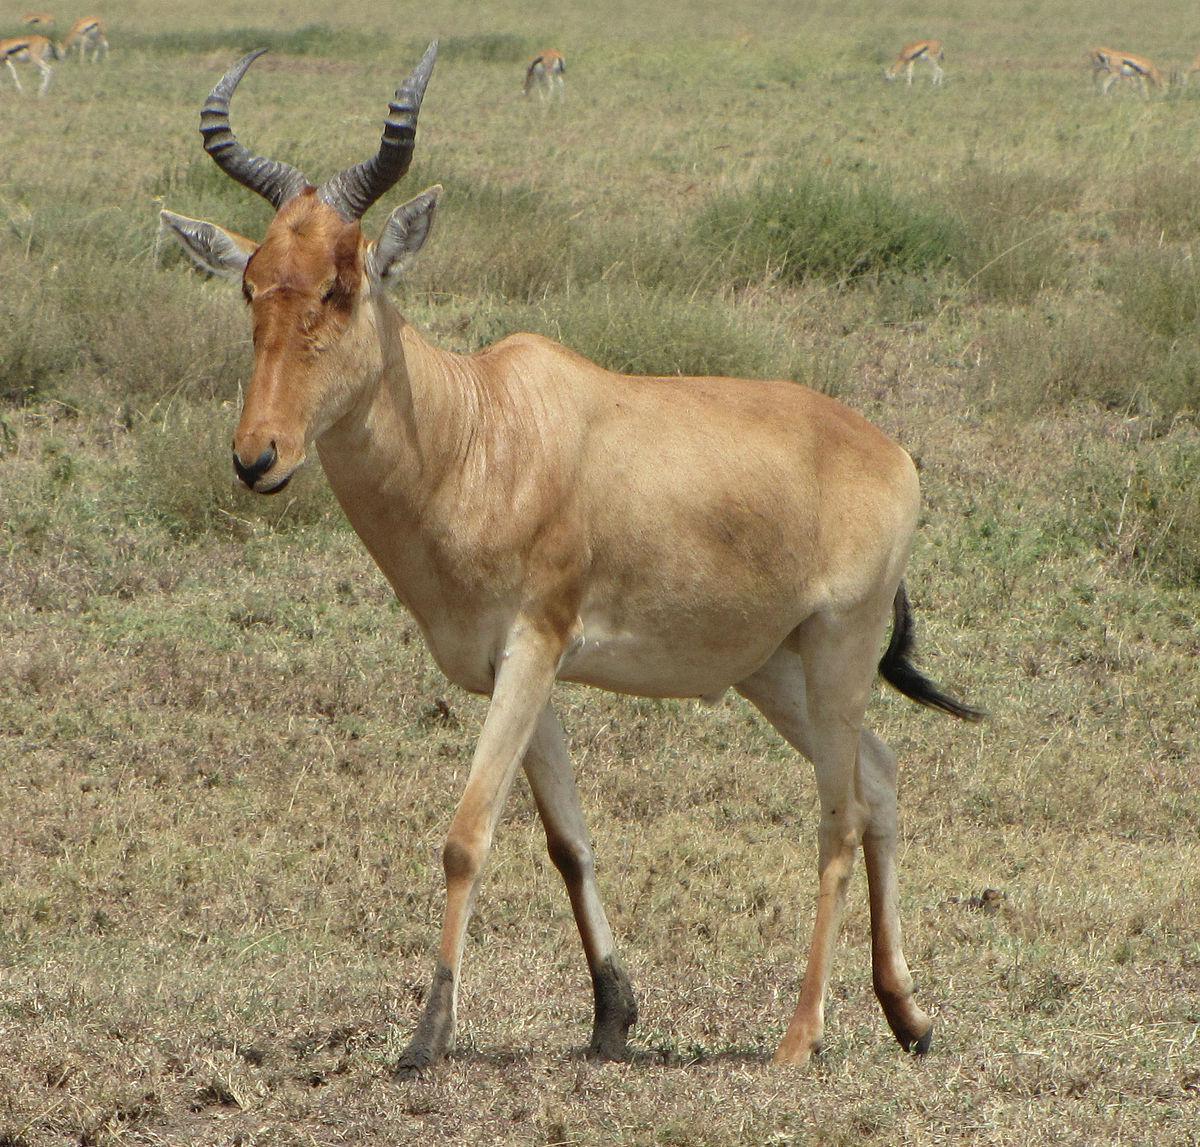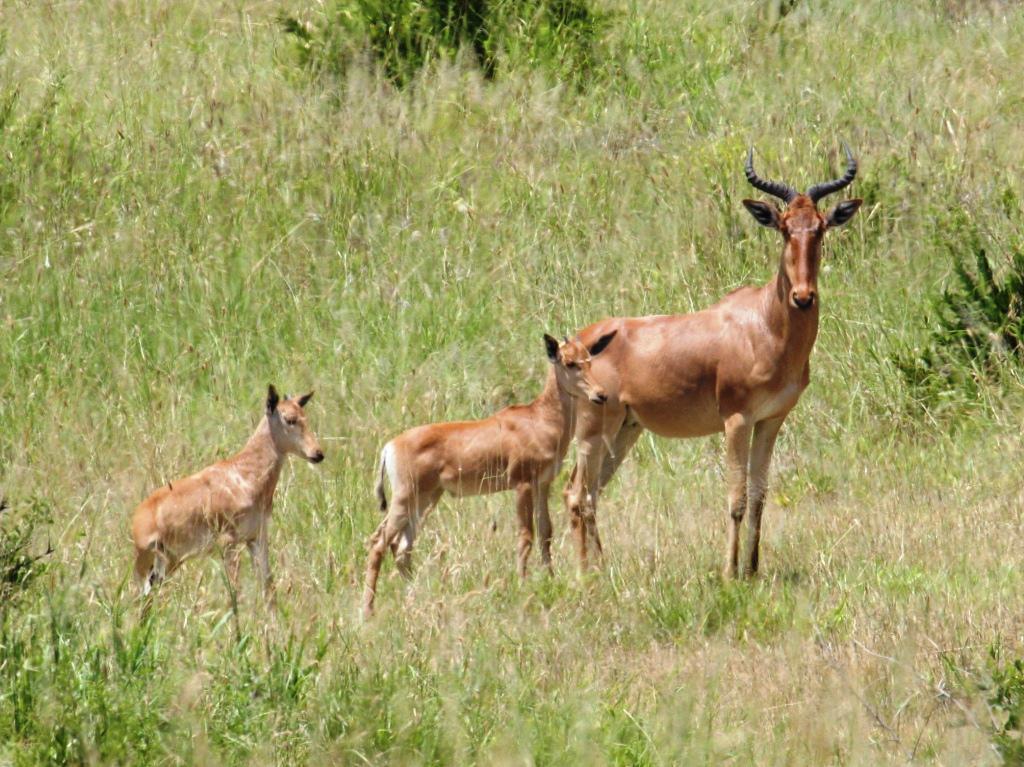The first image is the image on the left, the second image is the image on the right. For the images shown, is this caption "There is a grand total of 4 animals between both pictures." true? Answer yes or no. Yes. The first image is the image on the left, the second image is the image on the right. Analyze the images presented: Is the assertion "The right image contains at least twice as many hooved animals as the left image." valid? Answer yes or no. Yes. 